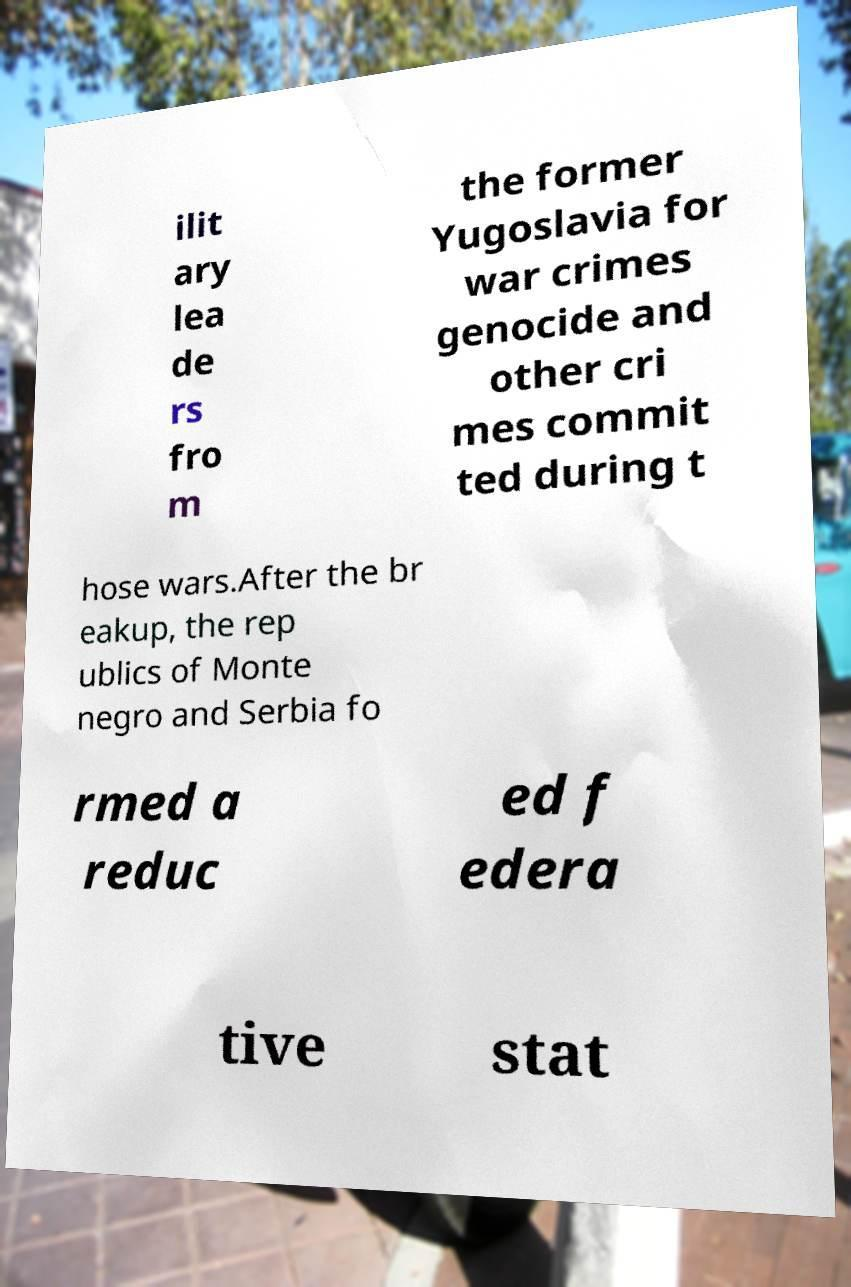What messages or text are displayed in this image? I need them in a readable, typed format. ilit ary lea de rs fro m the former Yugoslavia for war crimes genocide and other cri mes commit ted during t hose wars.After the br eakup, the rep ublics of Monte negro and Serbia fo rmed a reduc ed f edera tive stat 